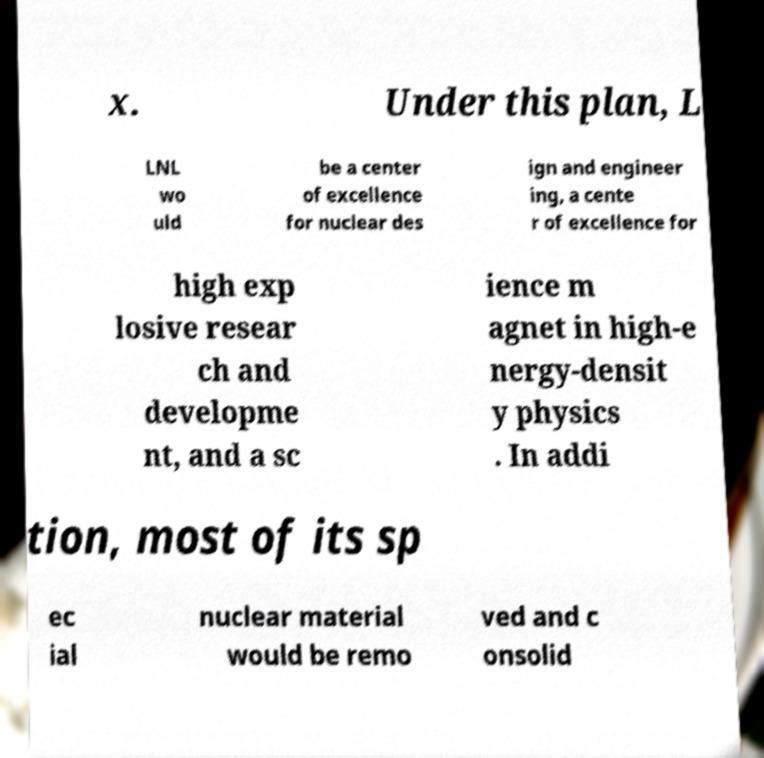What messages or text are displayed in this image? I need them in a readable, typed format. x. Under this plan, L LNL wo uld be a center of excellence for nuclear des ign and engineer ing, a cente r of excellence for high exp losive resear ch and developme nt, and a sc ience m agnet in high-e nergy-densit y physics . In addi tion, most of its sp ec ial nuclear material would be remo ved and c onsolid 